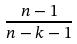<formula> <loc_0><loc_0><loc_500><loc_500>\frac { n - 1 } { n - k - 1 }</formula> 